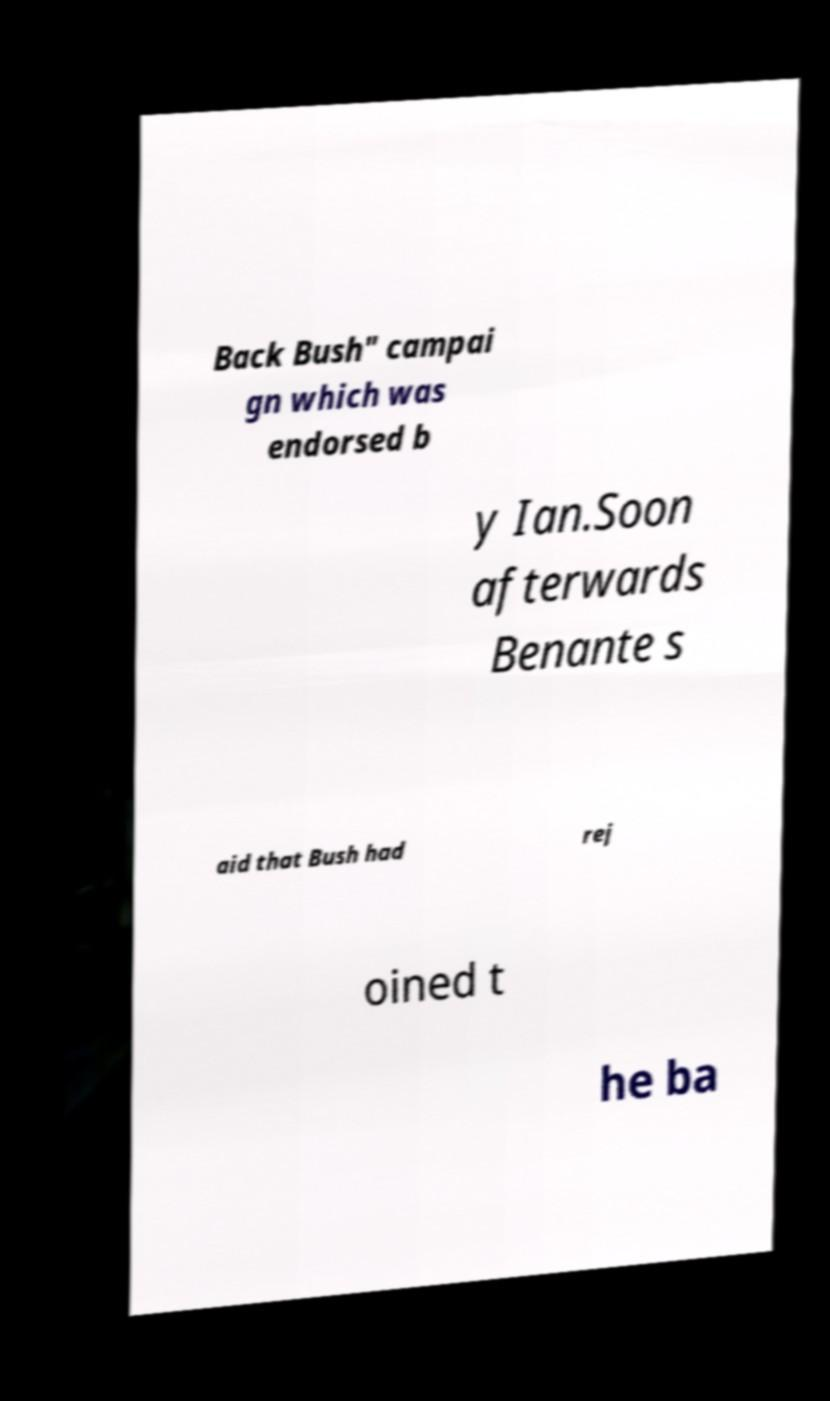Please identify and transcribe the text found in this image. Back Bush" campai gn which was endorsed b y Ian.Soon afterwards Benante s aid that Bush had rej oined t he ba 